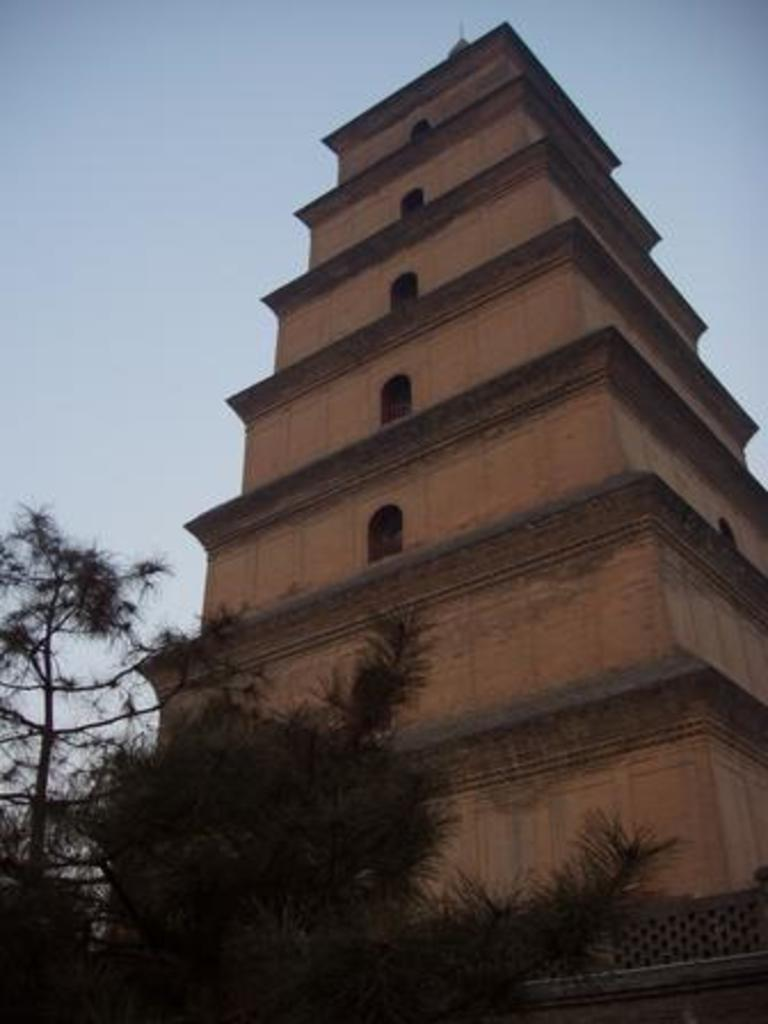What type of structure is present in the image? There is a building in the image. What can be seen at the bottom of the image? There are trees at the bottom of the image. What is visible at the top of the image? The sky is visible at the top of the image. What color is the vein visible in the image? There is no vein present in the image. What type of engine can be seen powering the building in the image? There is no engine present in the image, as buildings are not powered by engines. 